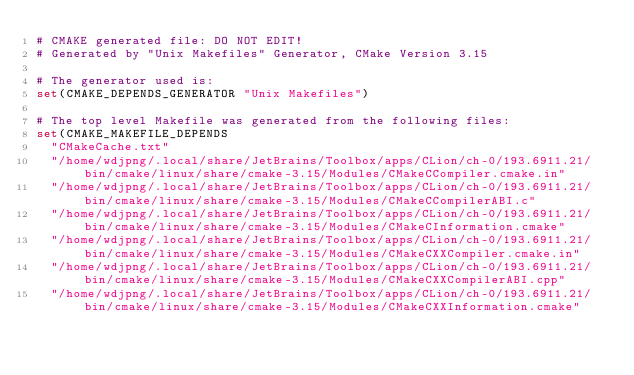<code> <loc_0><loc_0><loc_500><loc_500><_CMake_># CMAKE generated file: DO NOT EDIT!
# Generated by "Unix Makefiles" Generator, CMake Version 3.15

# The generator used is:
set(CMAKE_DEPENDS_GENERATOR "Unix Makefiles")

# The top level Makefile was generated from the following files:
set(CMAKE_MAKEFILE_DEPENDS
  "CMakeCache.txt"
  "/home/wdjpng/.local/share/JetBrains/Toolbox/apps/CLion/ch-0/193.6911.21/bin/cmake/linux/share/cmake-3.15/Modules/CMakeCCompiler.cmake.in"
  "/home/wdjpng/.local/share/JetBrains/Toolbox/apps/CLion/ch-0/193.6911.21/bin/cmake/linux/share/cmake-3.15/Modules/CMakeCCompilerABI.c"
  "/home/wdjpng/.local/share/JetBrains/Toolbox/apps/CLion/ch-0/193.6911.21/bin/cmake/linux/share/cmake-3.15/Modules/CMakeCInformation.cmake"
  "/home/wdjpng/.local/share/JetBrains/Toolbox/apps/CLion/ch-0/193.6911.21/bin/cmake/linux/share/cmake-3.15/Modules/CMakeCXXCompiler.cmake.in"
  "/home/wdjpng/.local/share/JetBrains/Toolbox/apps/CLion/ch-0/193.6911.21/bin/cmake/linux/share/cmake-3.15/Modules/CMakeCXXCompilerABI.cpp"
  "/home/wdjpng/.local/share/JetBrains/Toolbox/apps/CLion/ch-0/193.6911.21/bin/cmake/linux/share/cmake-3.15/Modules/CMakeCXXInformation.cmake"</code> 